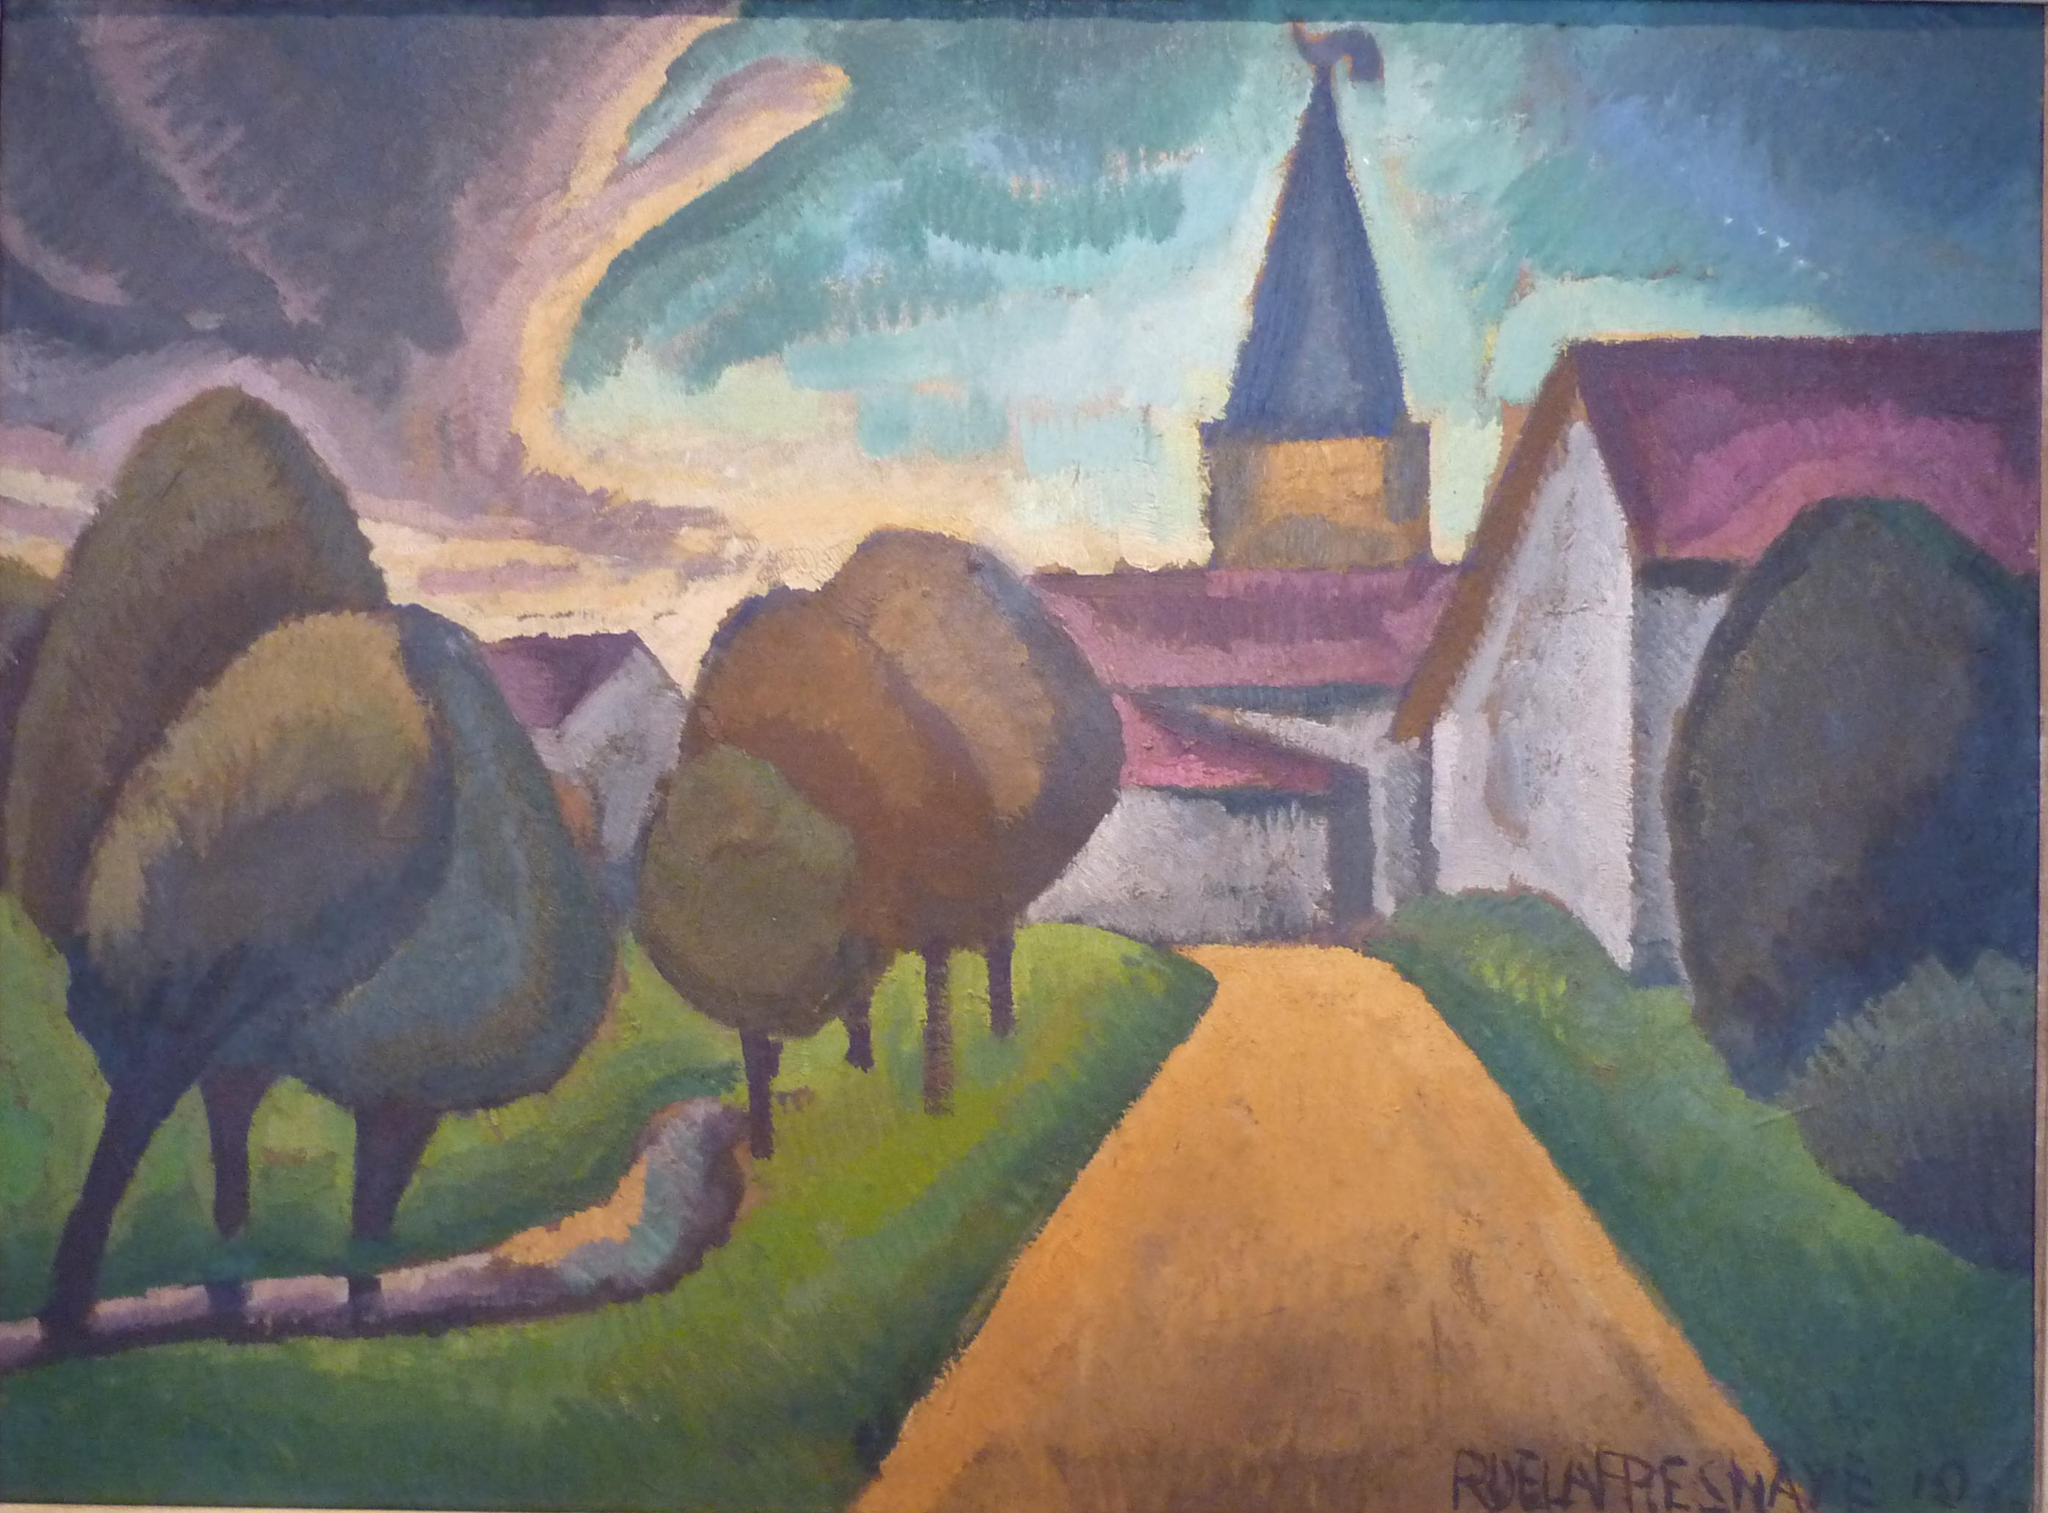What emotions does this painting evoke in you? This painting evokes a sense of serenity and nostalgia. The winding road leading towards the distant village invites a contemplative journey, reminiscent of peaceful countryside strolls. The harmonious blend of colors, with their soothing greens and blues, coupled with the gentle purples and warm yellows, adds to a calming, almost dreamy atmosphere. The church spire adds an element of reverence and spirituality, making the viewer reflect on the quiet, sacred moments of life. If this painting were the setting of a story, what kind of story would it be? In a story set within this painting, one might follow the journey of a young artist seeking inspiration in the serene countryside. Wandering down the winding road, he discovers the quaint village and its welcoming inhabitants who have a deep connection to the land. The village's history is rich with tales of resilience and unity, centered around the church, which not only serves as a place of worship but as a community gathering spot. The artist's interactions with the villagers and his observations of their simple, yet fulfilling lives, ignite a newfound passion in his work, capturing the essence of peace, spirituality, and camaraderie. Through his paintings, he brings the spirit of the village to life, sharing its quiet beauty with the world. Imagine the wind has a personality and can talk in this painting. What would it say about its journey? The wind, ever so playful and gentle, whispers softly, 'I am the breath of this enchanting land, weaving through the meadows and rustling the leaves. I have journeyed over hills and valleys, lovingly caressing each tree and whispering secrets to the swaying grass. As I pass through the village, I carry with me stories of generations, tales of joy and sorrow, laughter and tears. I rise to meet the heavens, where the spire points, mingling with the celestial music of the skies. My journey is unending, for I am the eternal traveler, binding the essence of this landscape with every gust and gentle breeze.' I have an idea; let's transform the elements of this painting into a magical realm. What roles would the trees, road, and church play? In a magical realm inspired by this painting, the trees would be ancient sentinels, guardians of the forest, their roots deeply intertwined with the earth's mystical energies. Each tree holds secrets of the past and can communicate with those who possess a pure heart and a desire to listen. The winding road would be the Path of Dreams, a sacred trail that shifts and changes, guiding travelers to their heart's true desires. The road is known to challenge travelers with quests, each step revealing new wonders and lessons. The church would be known as the Sanctuary of Stars, a celestial temple where the spire acts as a conduit to the heavens, enabling communication with the celestial beings and ancestors. Within its walls, the air hums with ancient hymns, and the villagers gather not only for worship but to harness the spiritual energies that protect and bless their community. 